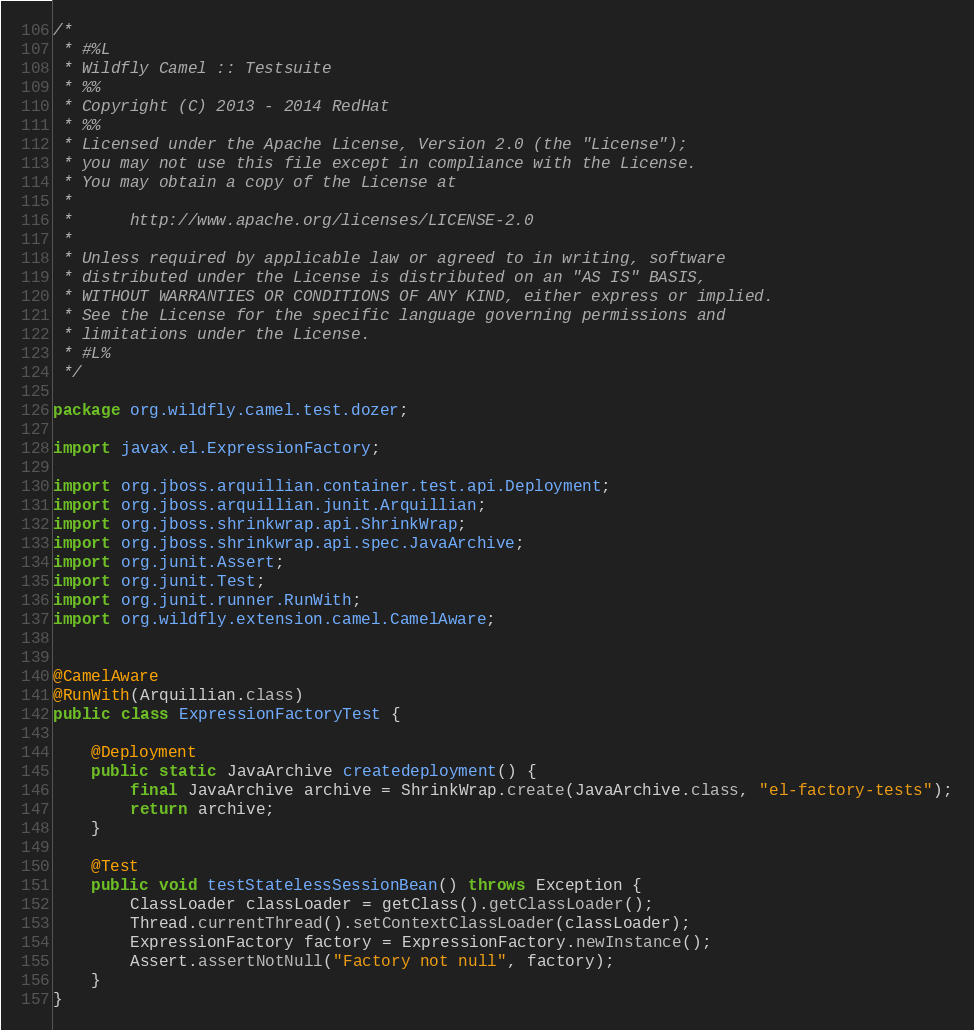<code> <loc_0><loc_0><loc_500><loc_500><_Java_>/*
 * #%L
 * Wildfly Camel :: Testsuite
 * %%
 * Copyright (C) 2013 - 2014 RedHat
 * %%
 * Licensed under the Apache License, Version 2.0 (the "License");
 * you may not use this file except in compliance with the License.
 * You may obtain a copy of the License at
 *
 *      http://www.apache.org/licenses/LICENSE-2.0
 *
 * Unless required by applicable law or agreed to in writing, software
 * distributed under the License is distributed on an "AS IS" BASIS,
 * WITHOUT WARRANTIES OR CONDITIONS OF ANY KIND, either express or implied.
 * See the License for the specific language governing permissions and
 * limitations under the License.
 * #L%
 */

package org.wildfly.camel.test.dozer;

import javax.el.ExpressionFactory;

import org.jboss.arquillian.container.test.api.Deployment;
import org.jboss.arquillian.junit.Arquillian;
import org.jboss.shrinkwrap.api.ShrinkWrap;
import org.jboss.shrinkwrap.api.spec.JavaArchive;
import org.junit.Assert;
import org.junit.Test;
import org.junit.runner.RunWith;
import org.wildfly.extension.camel.CamelAware;


@CamelAware
@RunWith(Arquillian.class)
public class ExpressionFactoryTest {

    @Deployment
    public static JavaArchive createdeployment() {
        final JavaArchive archive = ShrinkWrap.create(JavaArchive.class, "el-factory-tests");
        return archive;
    }

    @Test
    public void testStatelessSessionBean() throws Exception {
        ClassLoader classLoader = getClass().getClassLoader();
        Thread.currentThread().setContextClassLoader(classLoader);
        ExpressionFactory factory = ExpressionFactory.newInstance();
        Assert.assertNotNull("Factory not null", factory);
    }
}
</code> 